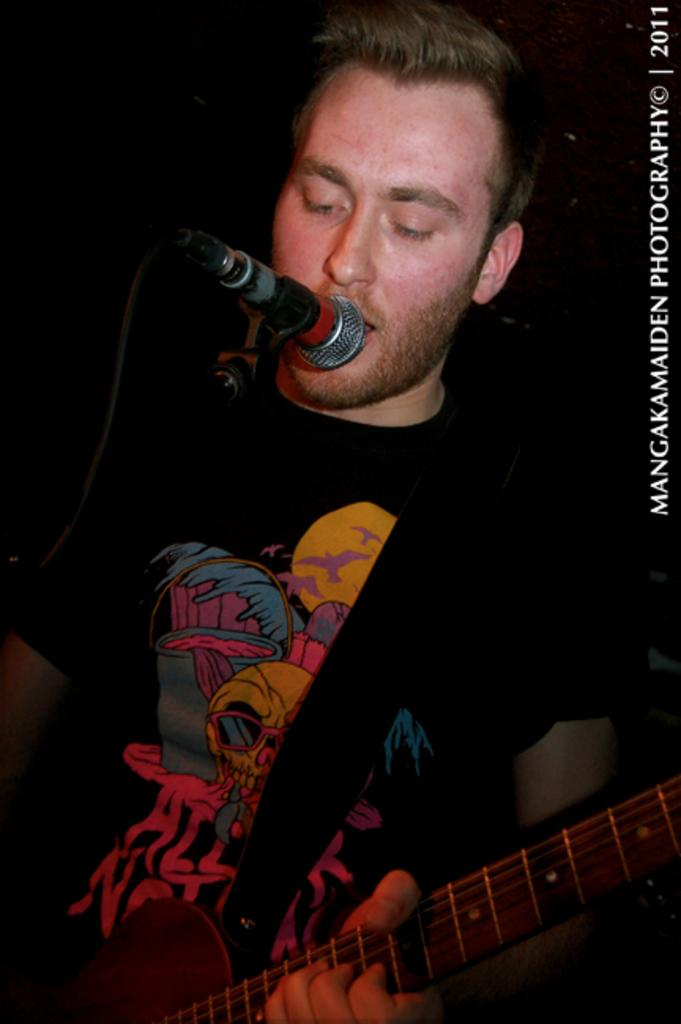What is the person in the image doing with the dog? The person is walking a dog on a leash. What type of protest is happening in the image? There is no protest depicted in the image; it features a person walking a dog on a leash. What is the weather like in the image? The provided facts do not mention the weather, so we cannot determine the weather conditions from the image. 